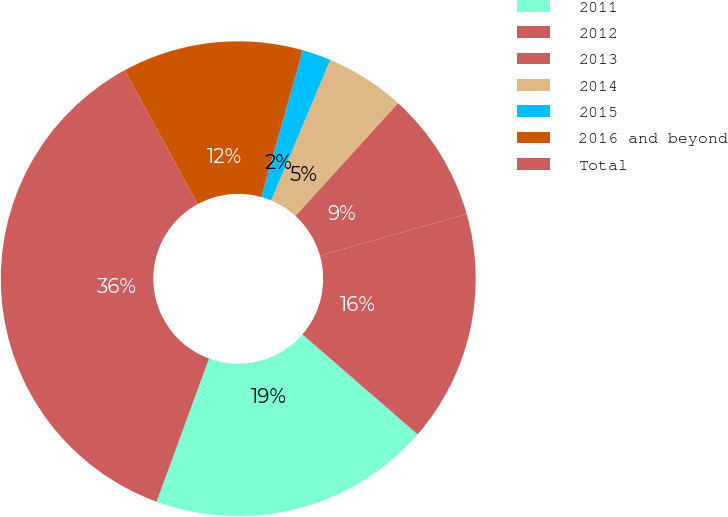<chart> <loc_0><loc_0><loc_500><loc_500><pie_chart><fcel>2011<fcel>2012<fcel>2013<fcel>2014<fcel>2015<fcel>2016 and beyond<fcel>Total<nl><fcel>19.22%<fcel>15.77%<fcel>8.86%<fcel>5.41%<fcel>1.96%<fcel>12.31%<fcel>36.48%<nl></chart> 